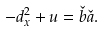<formula> <loc_0><loc_0><loc_500><loc_500>- d _ { x } ^ { 2 } + u = \check { b } \check { a } .</formula> 